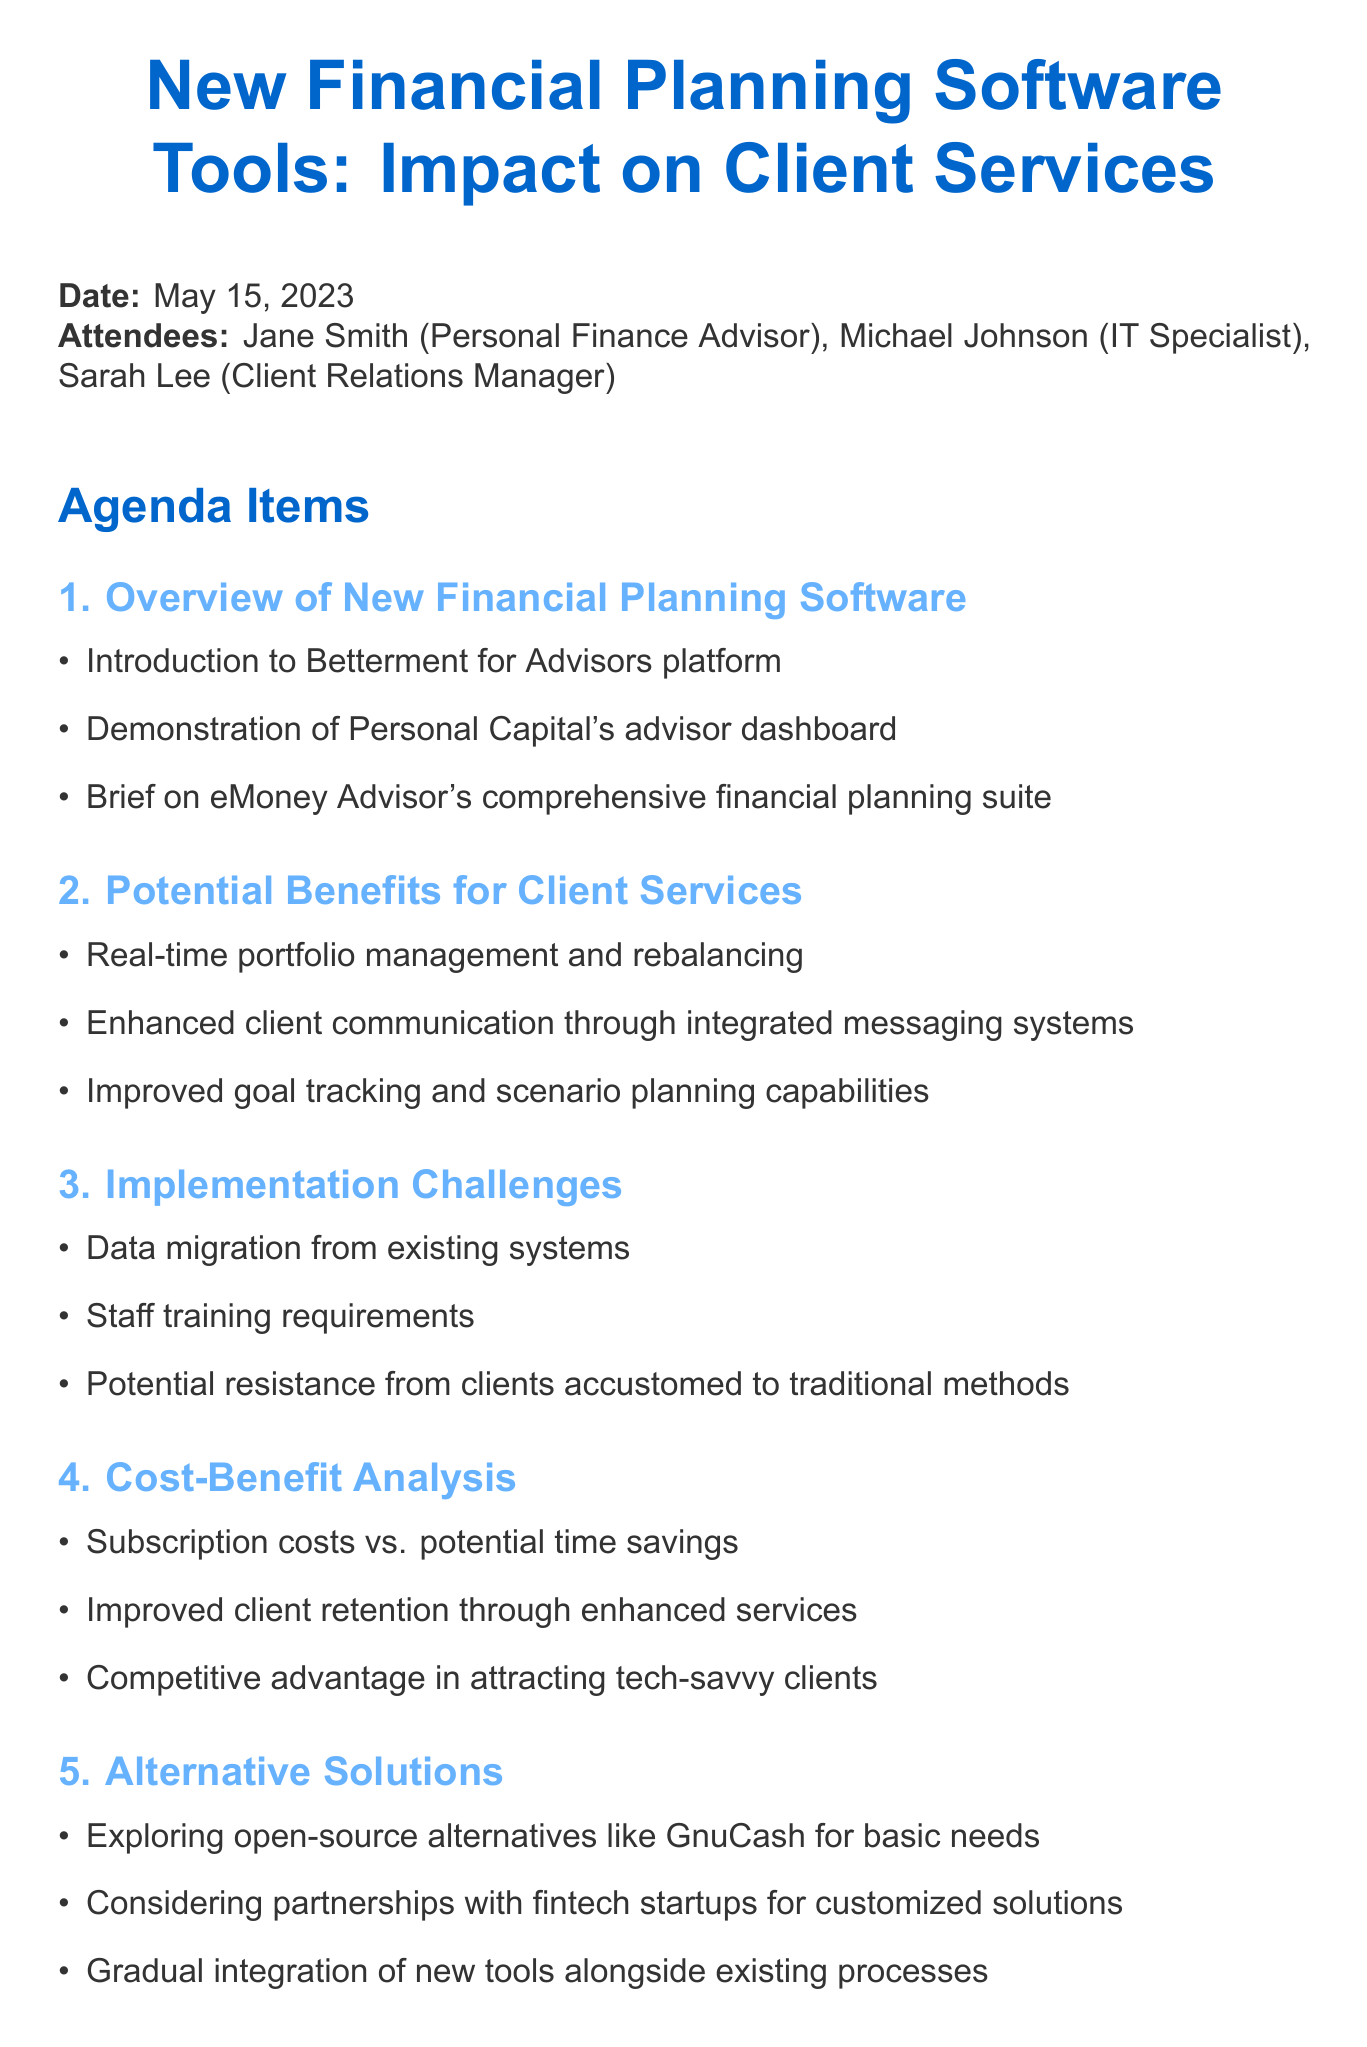What is the date of the meeting? The date of the meeting is explicitly mentioned at the beginning of the document.
Answer: May 15, 2023 Who is the Client Relations Manager? The document lists attendees with their roles, identifying Sarah Lee as the Client Relations Manager.
Answer: Sarah Lee What is one of the potential benefits for client services discussed? The document outlines several benefits, highlighting real-time portfolio management as one example.
Answer: Real-time portfolio management What is one implementation challenge mentioned? The document addresses several challenges and identifies data migration as one of them.
Answer: Data migration What is one action item assigned to Michael? The action items specify tasks for each attendee, stating that Michael is to research data security measures.
Answer: Research data security measures How many agenda items were discussed? The document lists agenda items with corresponding numbers, confirming the total of six discussed items.
Answer: Six What software platform was introduced in the meeting? The agenda includes an introduction to Betterment for Advisors specifically mentioned.
Answer: Betterment for Advisors What is the focus of the next steps in the meeting? The next steps aim at scheduling demonstrations and conducting client surveys, indicating they are focused on research and planning.
Answer: Research and planning What type of alternative solution was mentioned? The document discusses exploring open-source alternatives for basic needs as a potential solution.
Answer: Open-source alternatives 